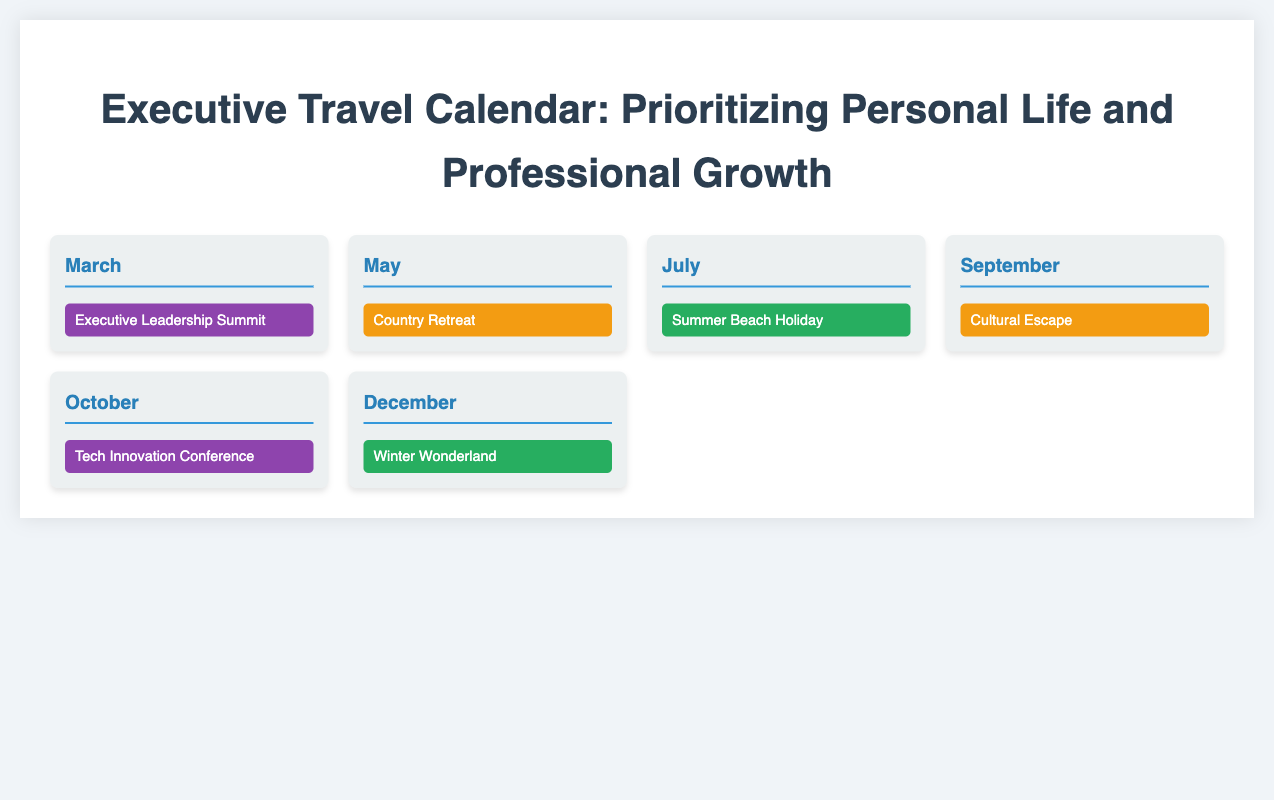What is the location of the Executive Leadership Summit? The document specifies that the location for the Executive Leadership Summit is Sedona, Arizona.
Answer: Sedona, Arizona How long is the Summer Beach Holiday? The duration of the Summer Beach Holiday is mentioned as 2 weeks (July 1 - July 14).
Answer: 2 weeks What activities are included in the Country Retreat? The activities for the Country Retreat include wine tasting, hot air balloon ride, and spa day, which can be found in the event details.
Answer: Wine tasting, hot air balloon ride, spa day Which month has the Tech Innovation Conference? The Tech Innovation Conference is scheduled in October, as seen in the provided calendar month.
Answer: October How many days does the Winter Wonderland last? The Winter Wonderland vacation lasts for 1 week from December 20 to December 27, as indicated in the event details.
Answer: 1 week What type of event is scheduled in July? The event scheduled in July is a family vacation, as categorized in the event title for that month.
Answer: Family vacation In which city is the Cultural Escape taking place? The location for the Cultural Escape is listed as Santa Fe, New Mexico in the document.
Answer: Santa Fe, New Mexico Which event overlaps with the family vacation in July? There are no overlapping events with the family vacation in July in the document; it is the only event for that month.
Answer: None What is the total number of professional retreats listed? The document lists two professional retreats within the calendar: the Executive Leadership Summit and the Tech Innovation Conference.
Answer: 2 